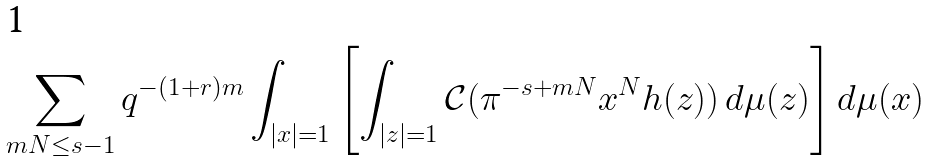<formula> <loc_0><loc_0><loc_500><loc_500>\sum _ { m N \leq s - 1 } q ^ { - ( 1 + r ) m } \int _ { | x | = 1 } \left [ \int _ { | z | = 1 } { \mathcal { C } } ( \pi ^ { - s + m N } x ^ { N } h ( z ) ) \, d \mu ( z ) \right ] d \mu ( x )</formula> 